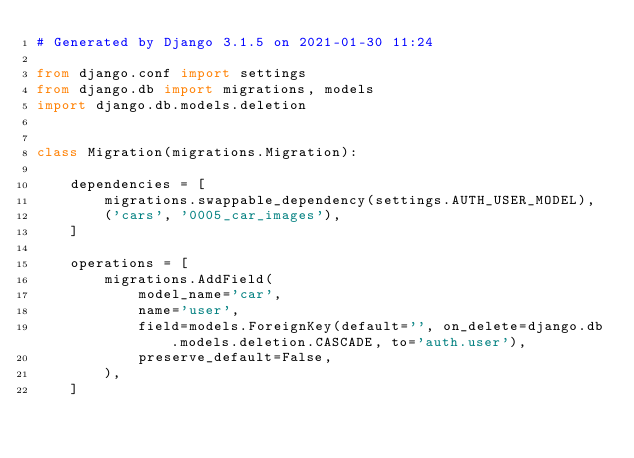<code> <loc_0><loc_0><loc_500><loc_500><_Python_># Generated by Django 3.1.5 on 2021-01-30 11:24

from django.conf import settings
from django.db import migrations, models
import django.db.models.deletion


class Migration(migrations.Migration):

    dependencies = [
        migrations.swappable_dependency(settings.AUTH_USER_MODEL),
        ('cars', '0005_car_images'),
    ]

    operations = [
        migrations.AddField(
            model_name='car',
            name='user',
            field=models.ForeignKey(default='', on_delete=django.db.models.deletion.CASCADE, to='auth.user'),
            preserve_default=False,
        ),
    ]
</code> 